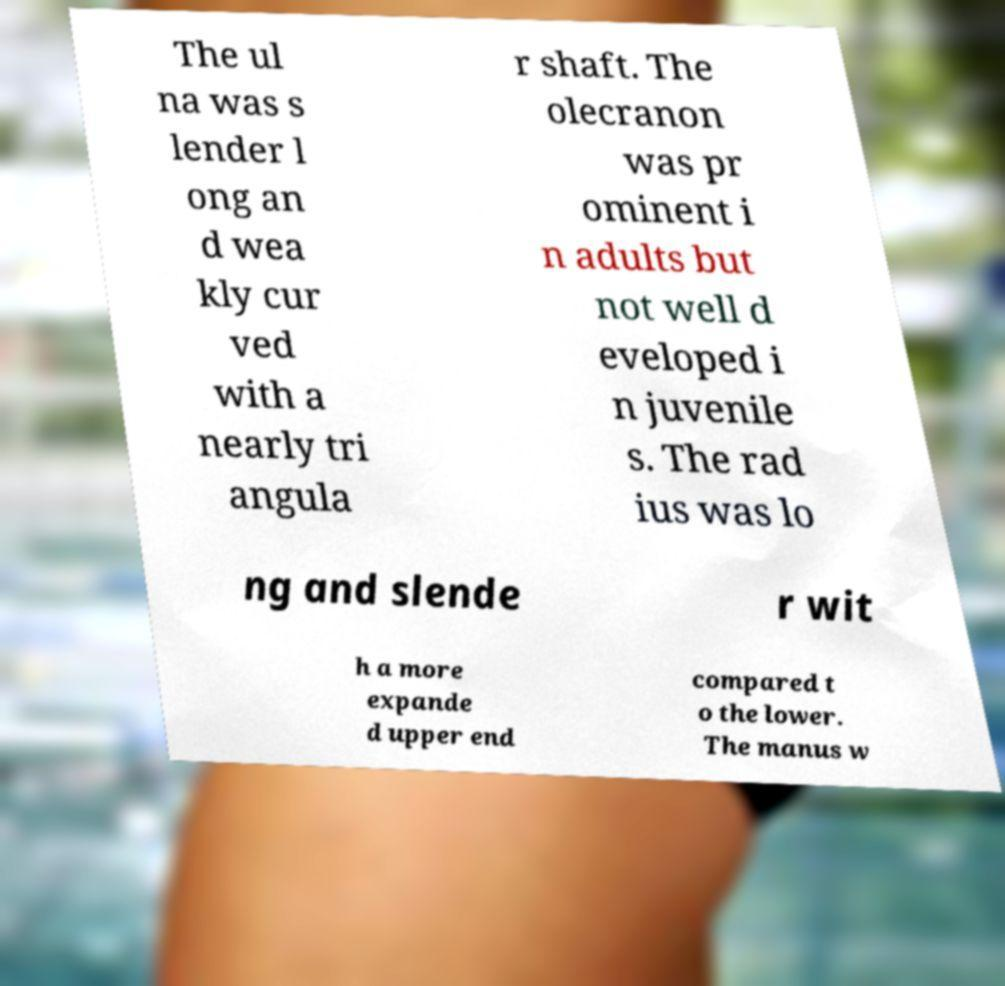Please identify and transcribe the text found in this image. The ul na was s lender l ong an d wea kly cur ved with a nearly tri angula r shaft. The olecranon was pr ominent i n adults but not well d eveloped i n juvenile s. The rad ius was lo ng and slende r wit h a more expande d upper end compared t o the lower. The manus w 